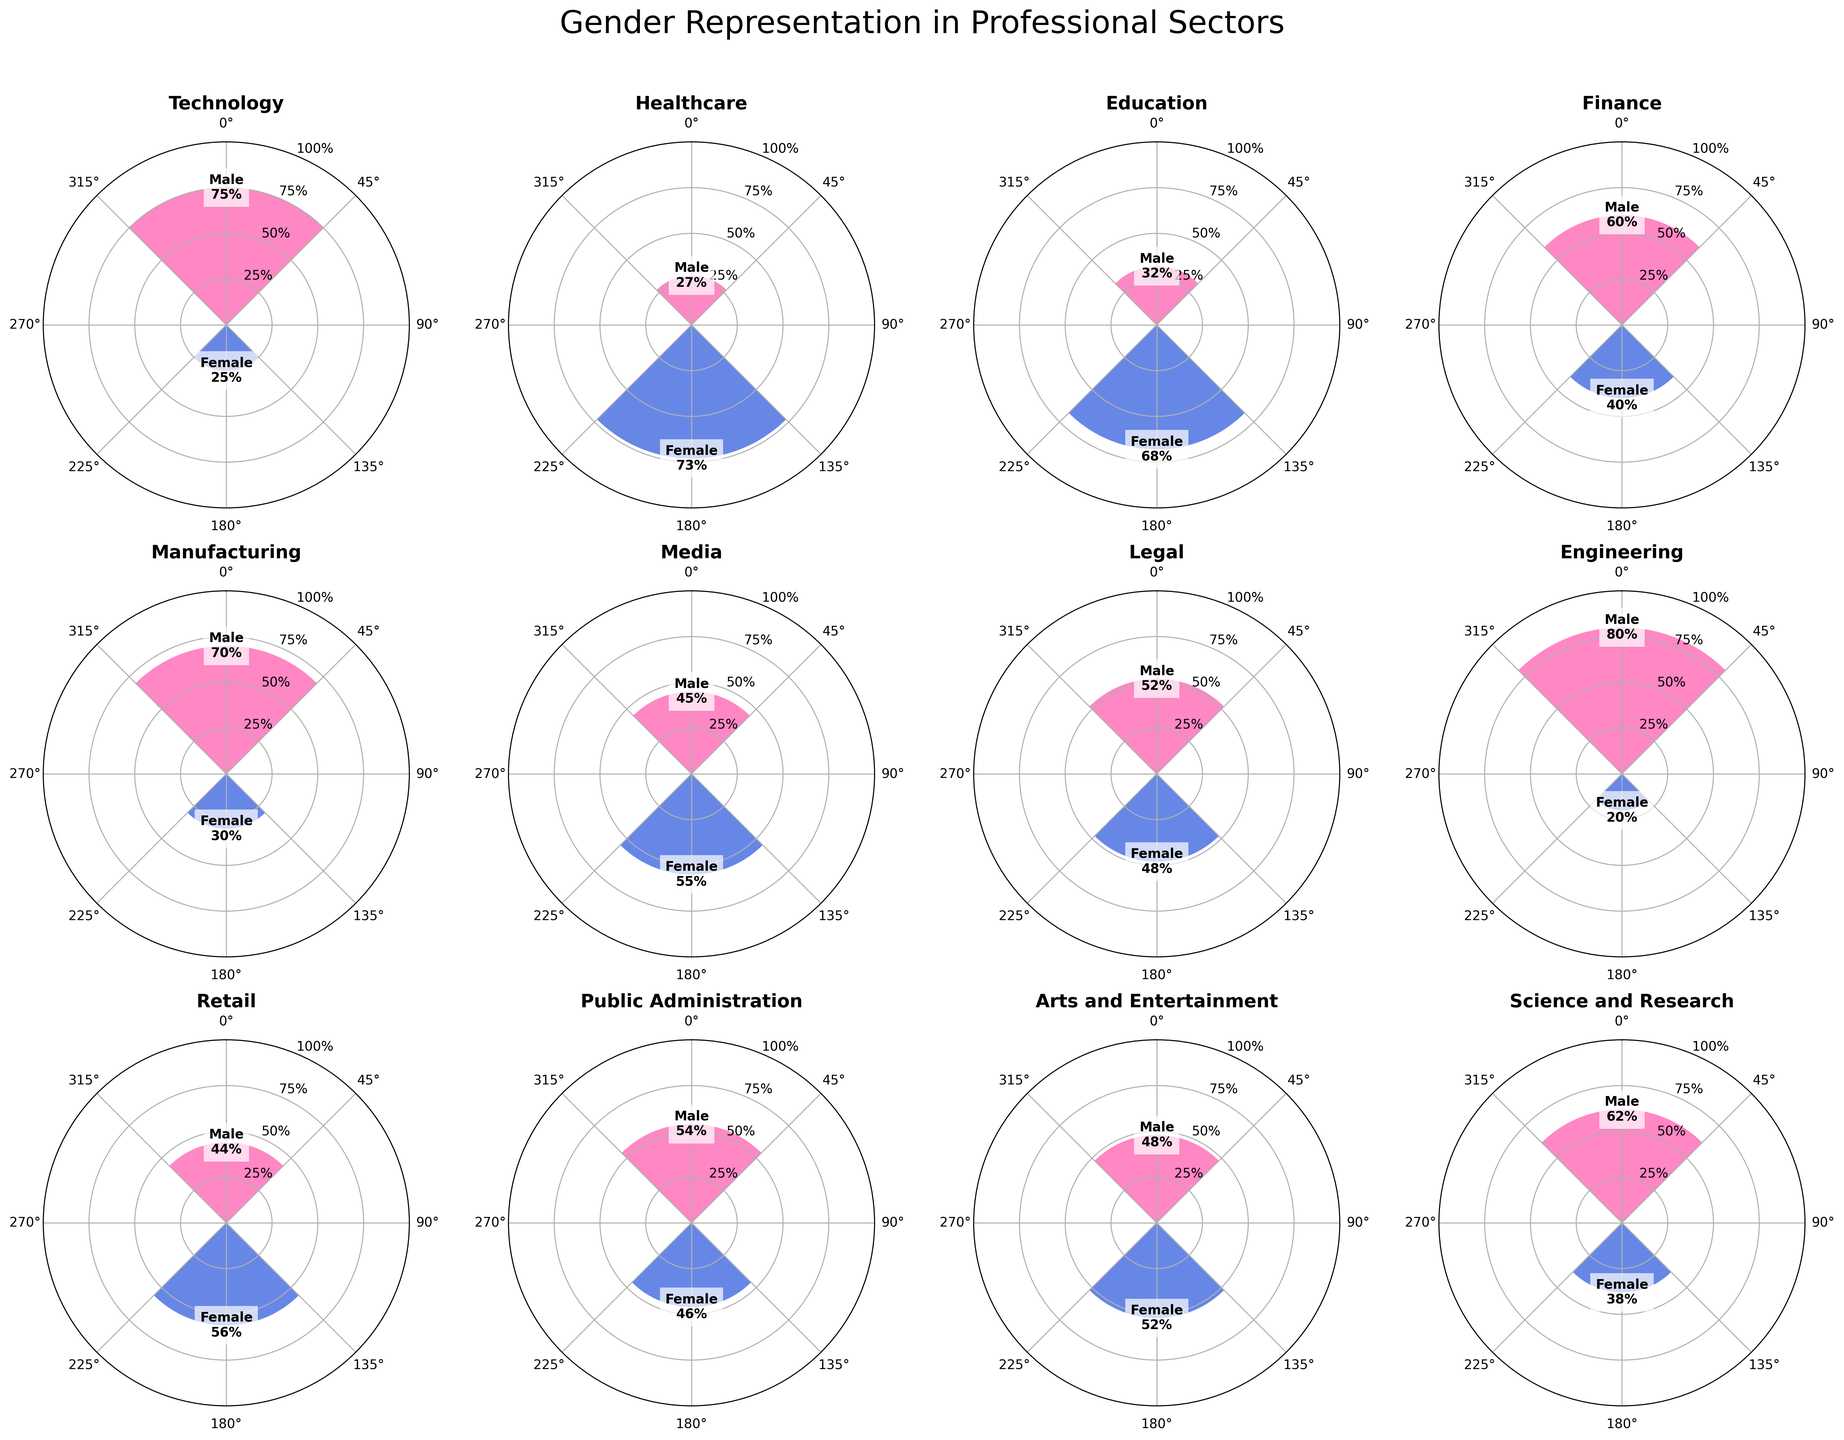What is the title of the figure? The title of the figure is given at the top of the plot. It reads "Gender Representation in Professional Sectors".
Answer: Gender Representation in Professional Sectors Which sector shows the highest percentage of male representation? By observing each subplot, we see that Engineering has the highest percentage of male representation at 80%.
Answer: Engineering In which sector are women represented more than men? List all such sectors. Healthcare, Education, Media, Retail, Arts and Entertainment show a higher percentage of female representation compared to male representation. This can be seen from the female percentages which exceed the respective male percentages in these sectors.
Answer: Healthcare, Education, Media, Retail, Arts and Entertainment What is the percentage difference in male representation between Technology and Engineering? The male representation in Technology is 75% and in Engineering is 80%. The difference is calculated by subtracting the two percentages: 80% - 75% = 5%.
Answer: 5% Which sector has almost equal representation of men and women? Looking at the bars, the Legal sector shows almost equal representation with 52% male and 48% female representation.
Answer: Legal Which sector has the lowest percentage of female representation? By examining each subplot, Engineering shows the lowest percentage of female representation at 20%.
Answer: Engineering What is the average female representation across all sectors? Sum the female percentages from each sector: (25% + 73% + 68% + 40% + 30% + 55% + 48% + 20% + 56% + 46% + 52% + 38%) = 601%. Divide this by the number of sectors (12): 601% / 12 ≈ 50.1%.
Answer: 50.1% Compare male representation in Media and Public Administration. Which is higher and by how much? Male representation in Media is 45% and in Public Administration is 54%. Public Administration has a higher representation: 54% - 45% = 9%.
Answer: Public Administration by 9% How do the percentages of male and female representation in Finance compare? In Finance, the male representation is 60% and the female representation is 40%. The male representation is higher by 60% - 40% = 20%.
Answer: Male is higher by 20% What patterns can you observe regarding female representation in STEM (Science, Technology, Engineering, Mathematics) sectors? In STEM sectors (Science and Research, Technology, Engineering), female representation is lower compared to male representation. Specifically, female percentages are 38% (Science and Research), 25% (Technology), and 20% (Engineering).
Answer: Lower female representation in STEM sectors 